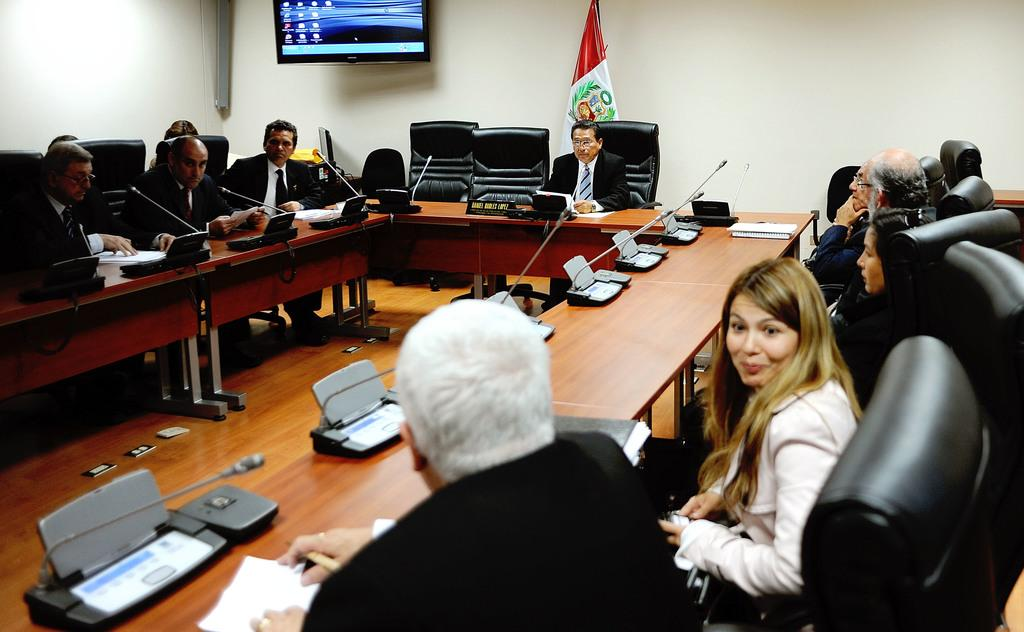How many people are in the image? There is a group of people in the image, but the exact number is not specified. Where are the people located in the image? The group of people is in a conference room. What can be seen in the background of the image? There is a white wall, a flag, and a television in the background of the image. What is present on every desk in the image? There is a microphone on every desk in the image. Is there any smoke coming from the pencil in the image? There is no pencil present in the image, and therefore no smoke can be observed. 